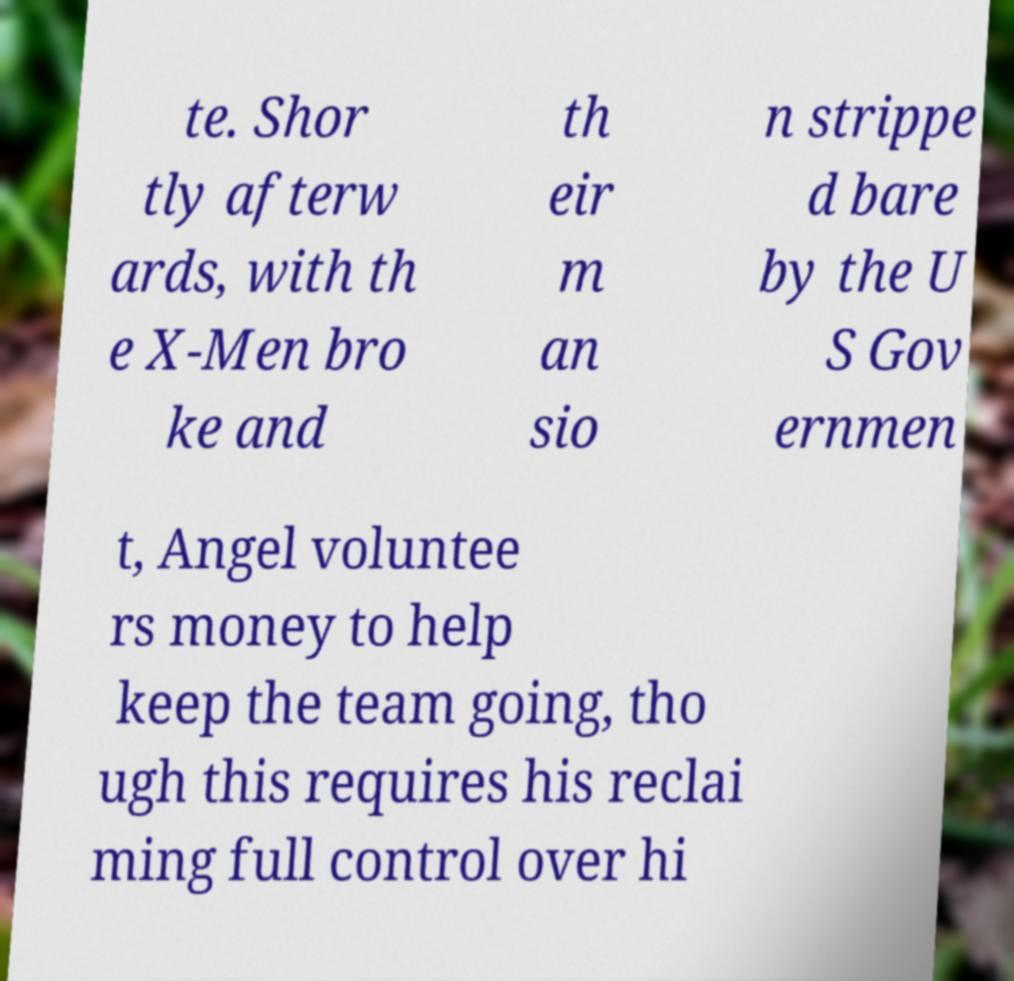Can you read and provide the text displayed in the image?This photo seems to have some interesting text. Can you extract and type it out for me? te. Shor tly afterw ards, with th e X-Men bro ke and th eir m an sio n strippe d bare by the U S Gov ernmen t, Angel voluntee rs money to help keep the team going, tho ugh this requires his reclai ming full control over hi 